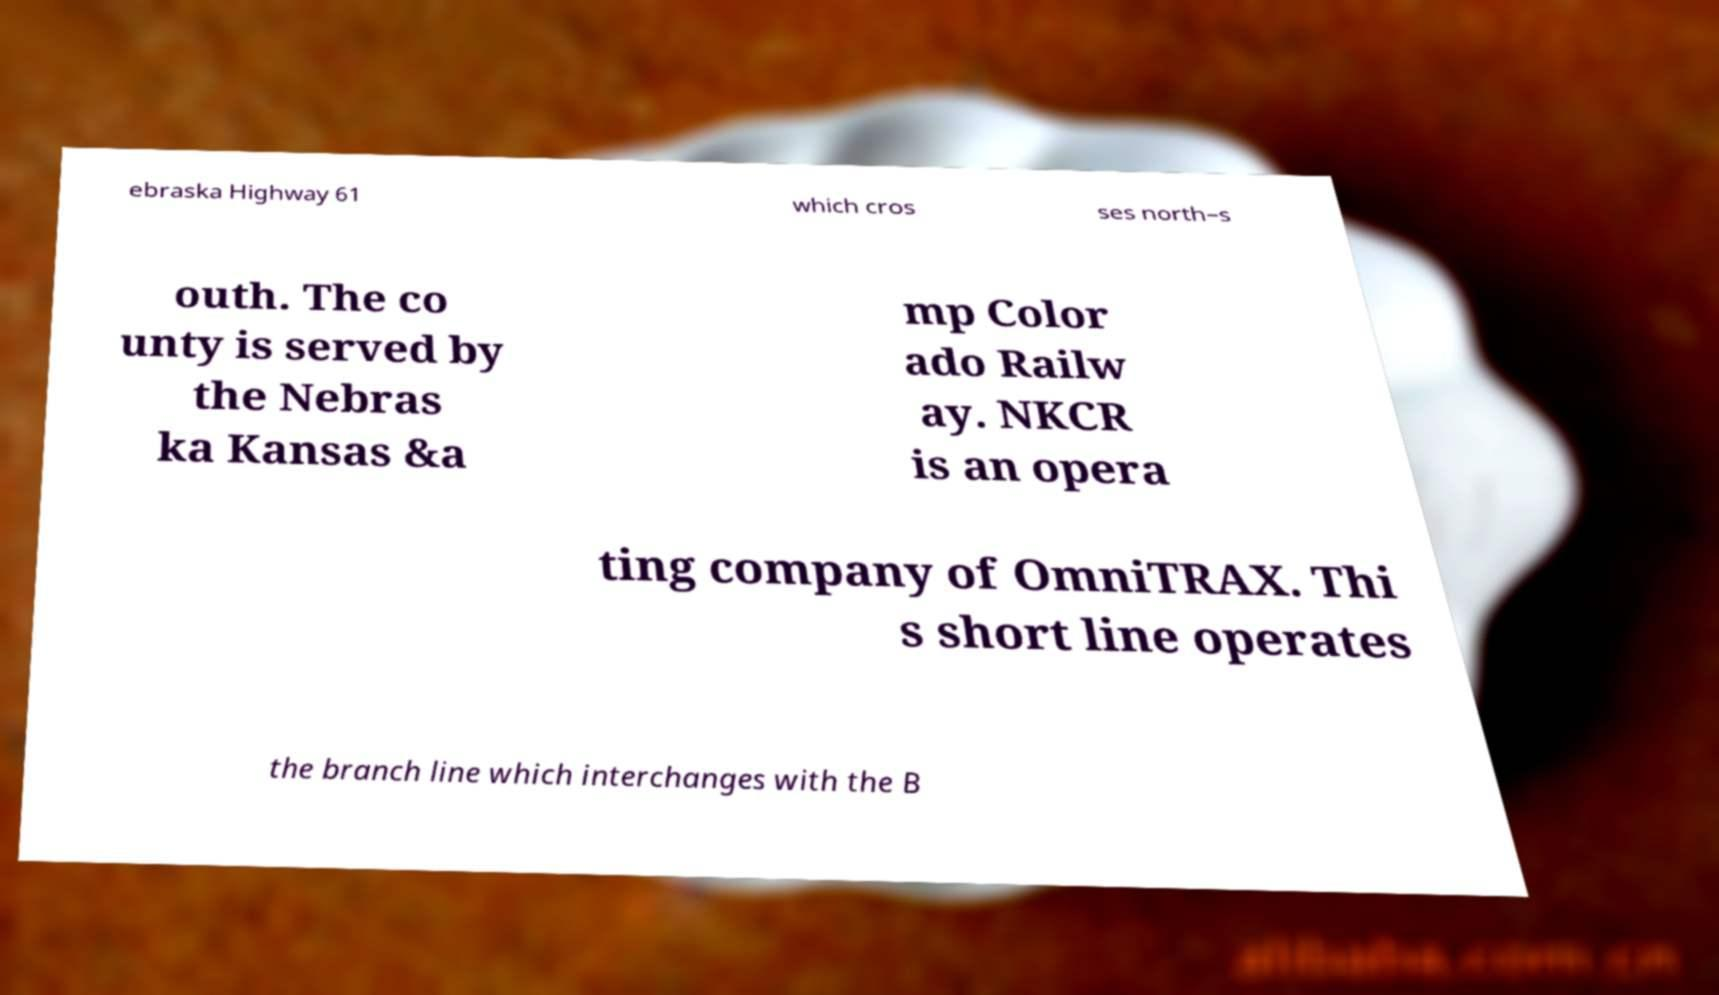There's text embedded in this image that I need extracted. Can you transcribe it verbatim? ebraska Highway 61 which cros ses north–s outh. The co unty is served by the Nebras ka Kansas &a mp Color ado Railw ay. NKCR is an opera ting company of OmniTRAX. Thi s short line operates the branch line which interchanges with the B 